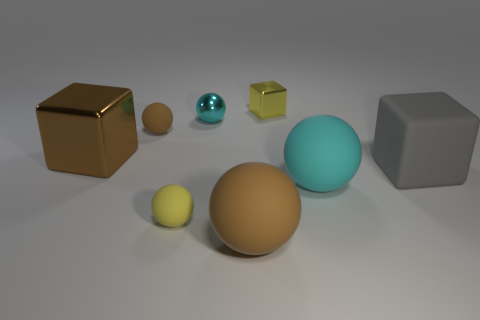Do the tiny block and the tiny sphere in front of the large cyan sphere have the same color?
Provide a succinct answer. Yes. Is the number of brown metal objects that are behind the tiny yellow shiny block less than the number of tiny yellow things right of the small cyan object?
Your answer should be compact. Yes. What number of other things are the same shape as the large brown shiny thing?
Your response must be concise. 2. Are there fewer brown matte objects in front of the tiny brown object than shiny blocks?
Your answer should be very brief. Yes. There is a big cube left of the matte cube; what material is it?
Ensure brevity in your answer.  Metal. What number of other objects are the same size as the matte block?
Your response must be concise. 3. Are there fewer yellow rubber things than brown rubber spheres?
Provide a succinct answer. Yes. What is the shape of the gray matte object?
Offer a very short reply. Cube. There is a rubber object behind the big brown metallic object; is its color the same as the big shiny block?
Provide a succinct answer. Yes. What is the shape of the matte thing that is in front of the big cyan sphere and behind the big brown ball?
Ensure brevity in your answer.  Sphere. 